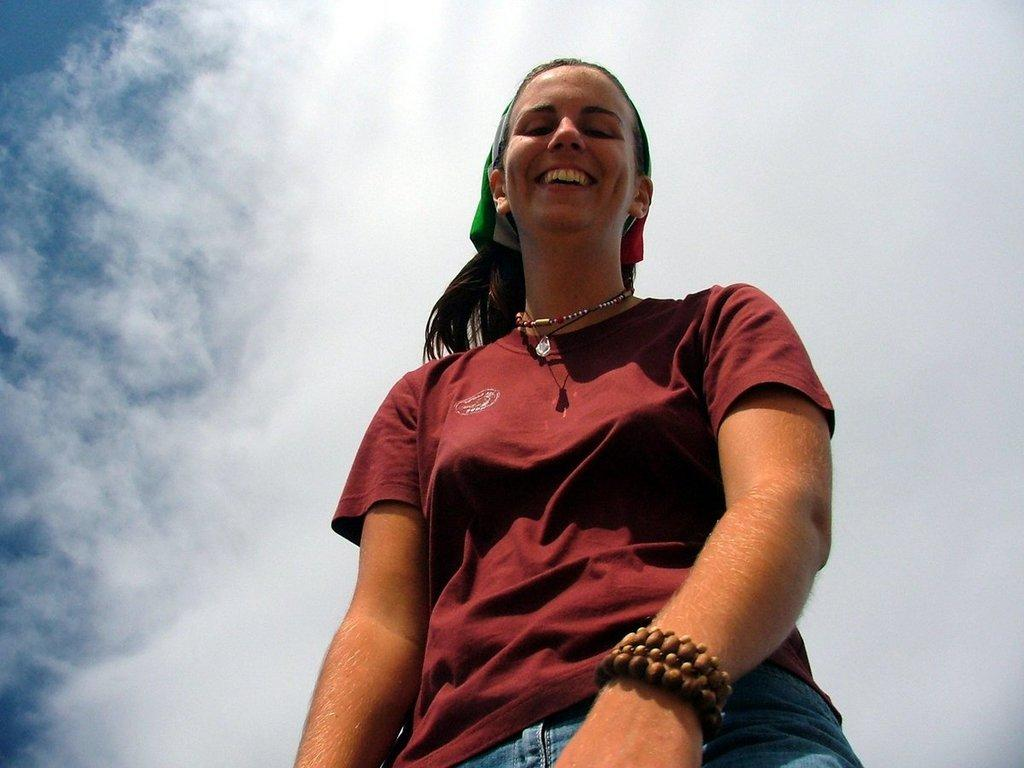Who is the main subject in the image? There is a lady in the image. What type of clothing is the lady wearing? The lady is wearing a T-shirt and jeans. What can be seen in the background of the image? The sky is visible in the background of the image. How many eyes does the rabbit have in the image? There is no rabbit present in the image, so it is not possible to determine the number of eyes it might have. 